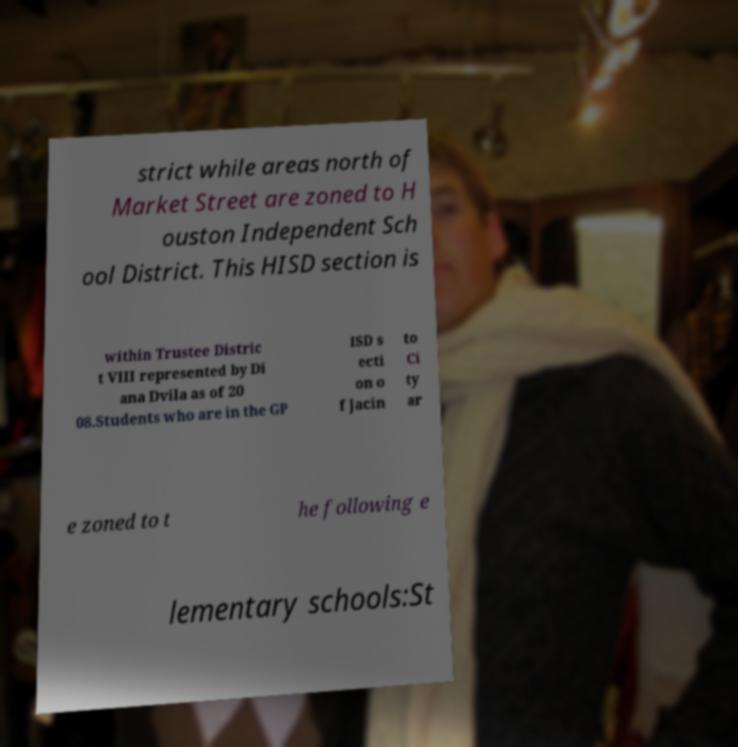Can you read and provide the text displayed in the image?This photo seems to have some interesting text. Can you extract and type it out for me? strict while areas north of Market Street are zoned to H ouston Independent Sch ool District. This HISD section is within Trustee Distric t VIII represented by Di ana Dvila as of 20 08.Students who are in the GP ISD s ecti on o f Jacin to Ci ty ar e zoned to t he following e lementary schools:St 